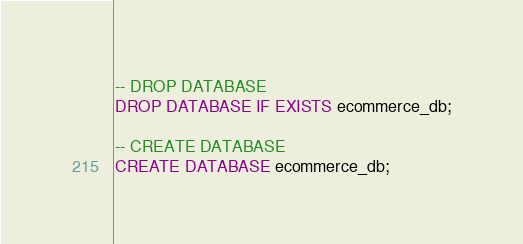<code> <loc_0><loc_0><loc_500><loc_500><_SQL_>-- DROP DATABASE
DROP DATABASE IF EXISTS ecommerce_db;

-- CREATE DATABASE
CREATE DATABASE ecommerce_db;
</code> 